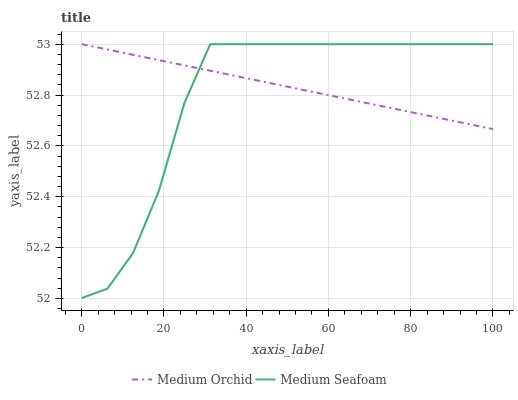Does Medium Seafoam have the minimum area under the curve?
Answer yes or no. Yes. Does Medium Orchid have the maximum area under the curve?
Answer yes or no. Yes. Does Medium Seafoam have the maximum area under the curve?
Answer yes or no. No. Is Medium Orchid the smoothest?
Answer yes or no. Yes. Is Medium Seafoam the roughest?
Answer yes or no. Yes. Is Medium Seafoam the smoothest?
Answer yes or no. No. Does Medium Seafoam have the lowest value?
Answer yes or no. Yes. Does Medium Seafoam have the highest value?
Answer yes or no. Yes. Does Medium Orchid intersect Medium Seafoam?
Answer yes or no. Yes. Is Medium Orchid less than Medium Seafoam?
Answer yes or no. No. Is Medium Orchid greater than Medium Seafoam?
Answer yes or no. No. 